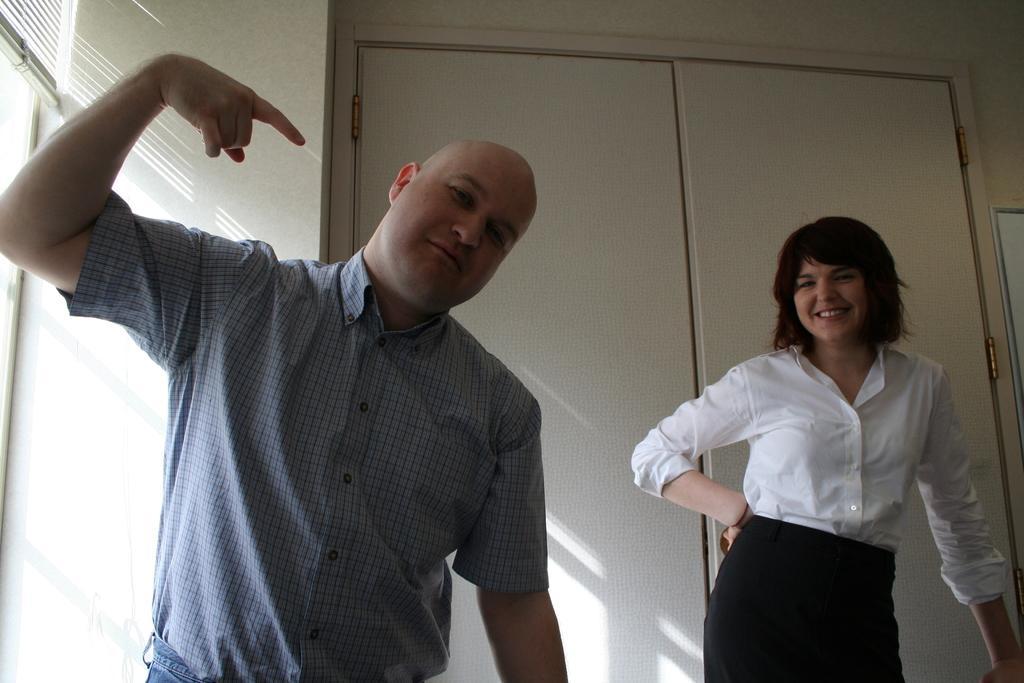Could you give a brief overview of what you see in this image? On the left there is a person in blue shirt and there are window, window blind and wall. On the right there is a woman in white shirt standing. In the background it is door. 